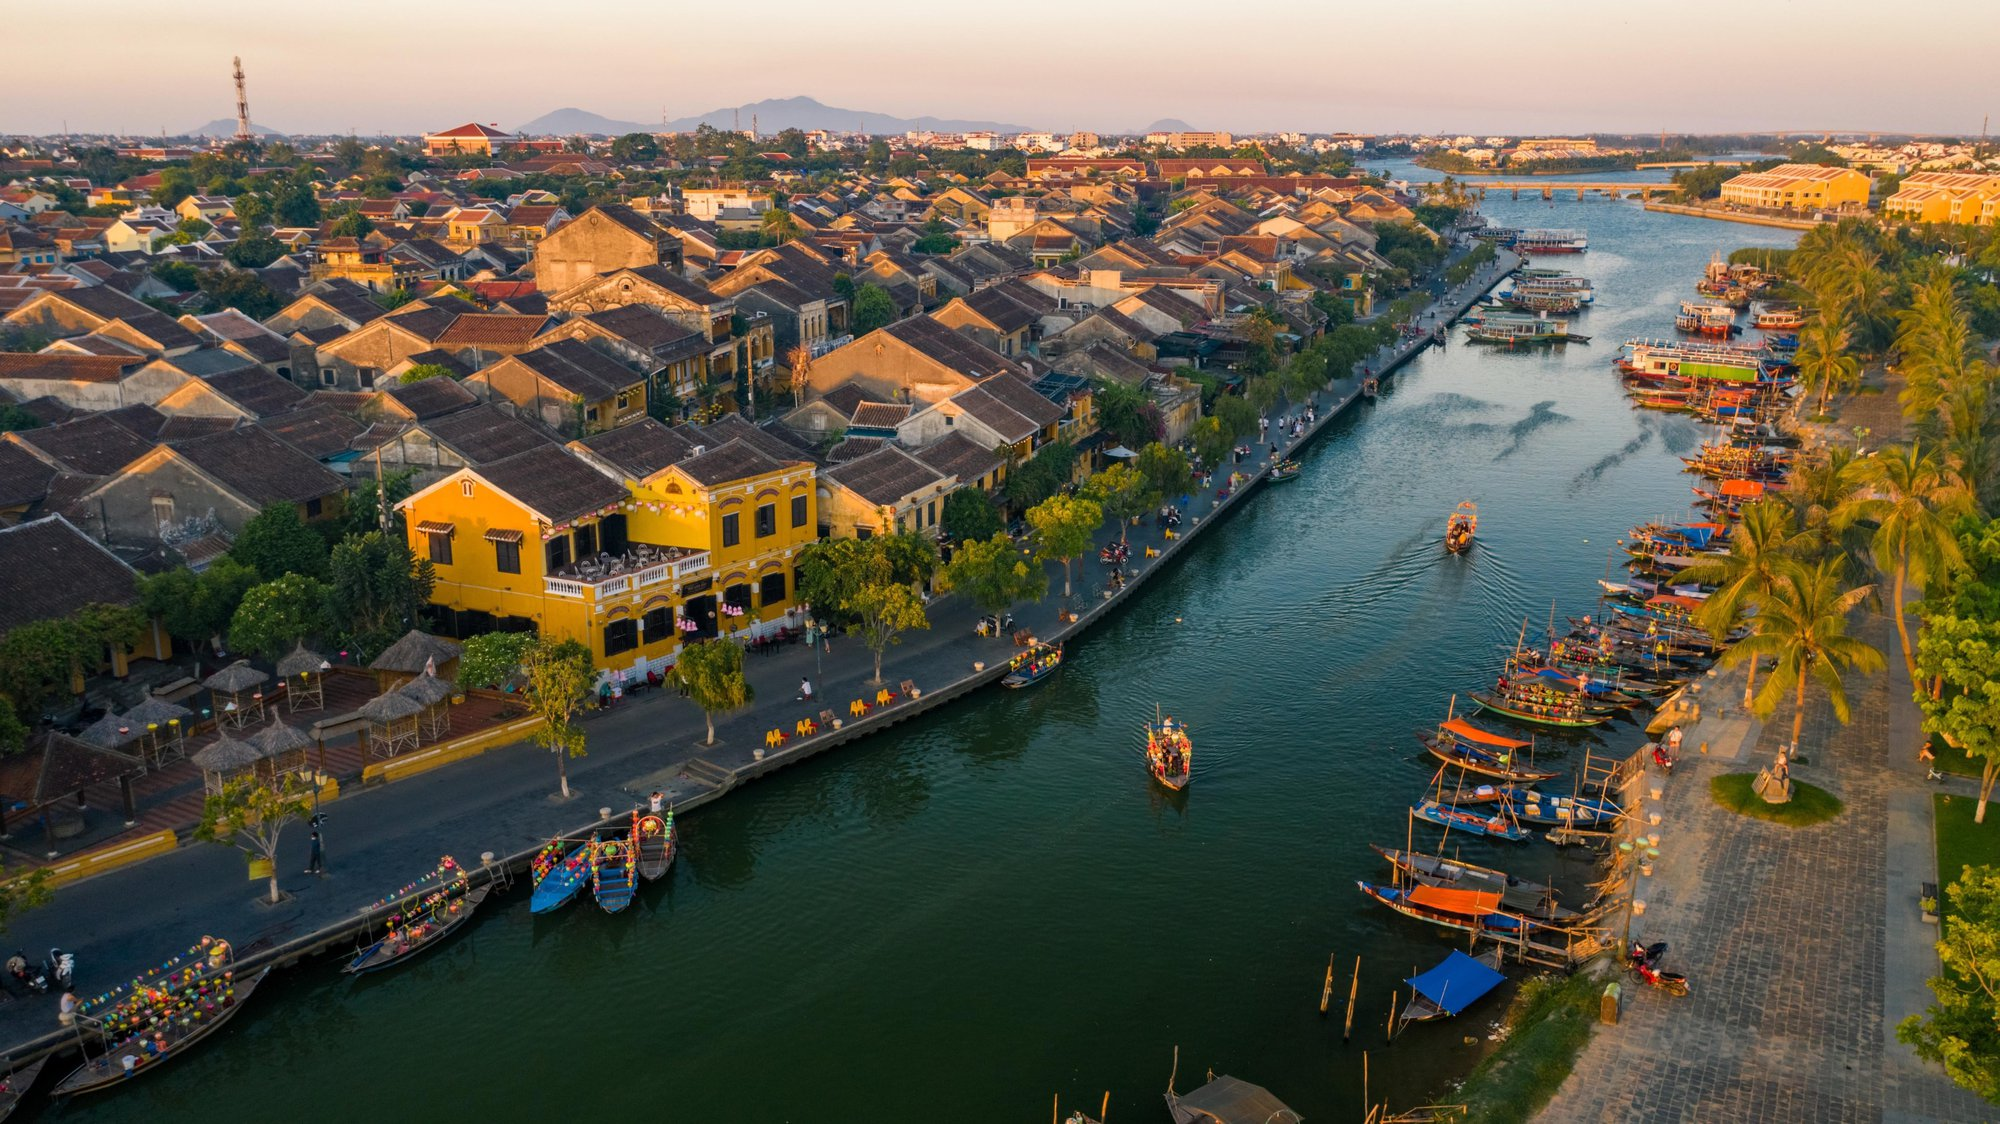Describe the types of boats visible in the image and their possible uses in daily life. The image showcases a variety of traditional wooden boats, each adorned with an array of vibrant colored lanterns. These boats are likely used primarily for tourism, offering scenic river cruises along the Thu Bon River. With their flat bottoms and wide hulls, these boats are well-suited for navigating the shallow waters. Beyond their use in tourism, these boats can also serve functional purposes such as aiding in the daily transportation of locals across the river. Additionally, they may play a significant role in local festivals and community gatherings, adding a touch of cultural heritage and festivity to events. 